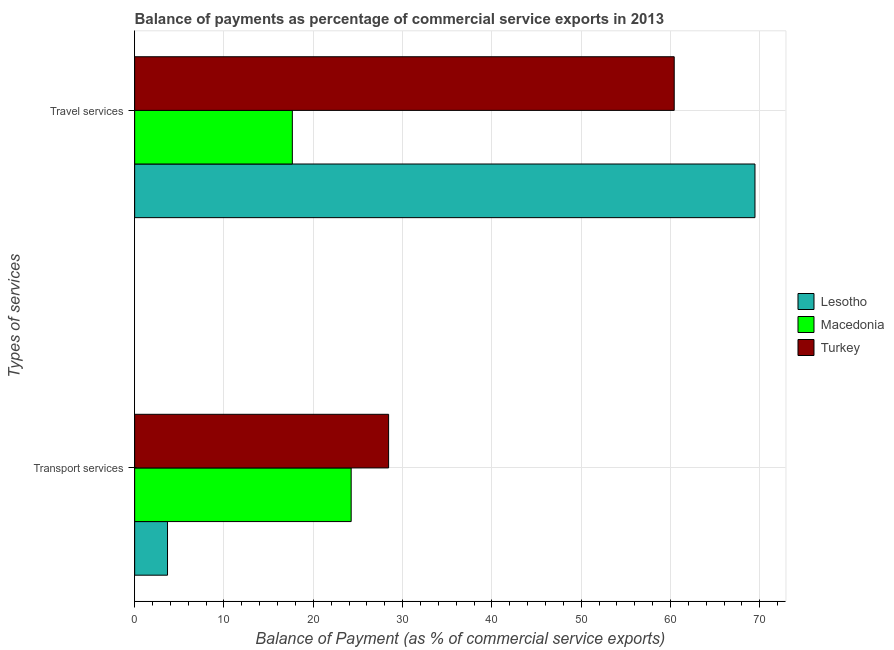How many different coloured bars are there?
Give a very brief answer. 3. How many bars are there on the 1st tick from the top?
Make the answer very short. 3. How many bars are there on the 2nd tick from the bottom?
Make the answer very short. 3. What is the label of the 1st group of bars from the top?
Offer a very short reply. Travel services. What is the balance of payments of travel services in Turkey?
Ensure brevity in your answer.  60.42. Across all countries, what is the maximum balance of payments of transport services?
Your answer should be very brief. 28.43. Across all countries, what is the minimum balance of payments of transport services?
Ensure brevity in your answer.  3.68. In which country was the balance of payments of travel services maximum?
Your response must be concise. Lesotho. In which country was the balance of payments of transport services minimum?
Your response must be concise. Lesotho. What is the total balance of payments of transport services in the graph?
Keep it short and to the point. 56.36. What is the difference between the balance of payments of transport services in Turkey and that in Macedonia?
Your answer should be compact. 4.19. What is the difference between the balance of payments of transport services in Turkey and the balance of payments of travel services in Macedonia?
Provide a succinct answer. 10.78. What is the average balance of payments of travel services per country?
Your answer should be compact. 49.18. What is the difference between the balance of payments of travel services and balance of payments of transport services in Turkey?
Ensure brevity in your answer.  31.98. In how many countries, is the balance of payments of transport services greater than 46 %?
Offer a very short reply. 0. What is the ratio of the balance of payments of travel services in Lesotho to that in Turkey?
Make the answer very short. 1.15. In how many countries, is the balance of payments of transport services greater than the average balance of payments of transport services taken over all countries?
Your answer should be compact. 2. What does the 2nd bar from the top in Transport services represents?
Make the answer very short. Macedonia. What does the 1st bar from the bottom in Travel services represents?
Offer a very short reply. Lesotho. How many bars are there?
Your answer should be very brief. 6. How many legend labels are there?
Make the answer very short. 3. How are the legend labels stacked?
Provide a short and direct response. Vertical. What is the title of the graph?
Offer a terse response. Balance of payments as percentage of commercial service exports in 2013. What is the label or title of the X-axis?
Provide a succinct answer. Balance of Payment (as % of commercial service exports). What is the label or title of the Y-axis?
Your answer should be very brief. Types of services. What is the Balance of Payment (as % of commercial service exports) in Lesotho in Transport services?
Ensure brevity in your answer.  3.68. What is the Balance of Payment (as % of commercial service exports) in Macedonia in Transport services?
Make the answer very short. 24.24. What is the Balance of Payment (as % of commercial service exports) of Turkey in Transport services?
Your response must be concise. 28.43. What is the Balance of Payment (as % of commercial service exports) of Lesotho in Travel services?
Provide a short and direct response. 69.46. What is the Balance of Payment (as % of commercial service exports) of Macedonia in Travel services?
Provide a succinct answer. 17.66. What is the Balance of Payment (as % of commercial service exports) of Turkey in Travel services?
Offer a terse response. 60.42. Across all Types of services, what is the maximum Balance of Payment (as % of commercial service exports) in Lesotho?
Provide a succinct answer. 69.46. Across all Types of services, what is the maximum Balance of Payment (as % of commercial service exports) in Macedonia?
Your response must be concise. 24.24. Across all Types of services, what is the maximum Balance of Payment (as % of commercial service exports) of Turkey?
Provide a succinct answer. 60.42. Across all Types of services, what is the minimum Balance of Payment (as % of commercial service exports) of Lesotho?
Give a very brief answer. 3.68. Across all Types of services, what is the minimum Balance of Payment (as % of commercial service exports) in Macedonia?
Offer a terse response. 17.66. Across all Types of services, what is the minimum Balance of Payment (as % of commercial service exports) of Turkey?
Provide a short and direct response. 28.43. What is the total Balance of Payment (as % of commercial service exports) in Lesotho in the graph?
Your response must be concise. 73.14. What is the total Balance of Payment (as % of commercial service exports) in Macedonia in the graph?
Ensure brevity in your answer.  41.9. What is the total Balance of Payment (as % of commercial service exports) in Turkey in the graph?
Offer a terse response. 88.85. What is the difference between the Balance of Payment (as % of commercial service exports) of Lesotho in Transport services and that in Travel services?
Offer a very short reply. -65.77. What is the difference between the Balance of Payment (as % of commercial service exports) in Macedonia in Transport services and that in Travel services?
Keep it short and to the point. 6.59. What is the difference between the Balance of Payment (as % of commercial service exports) of Turkey in Transport services and that in Travel services?
Offer a terse response. -31.98. What is the difference between the Balance of Payment (as % of commercial service exports) of Lesotho in Transport services and the Balance of Payment (as % of commercial service exports) of Macedonia in Travel services?
Offer a very short reply. -13.98. What is the difference between the Balance of Payment (as % of commercial service exports) in Lesotho in Transport services and the Balance of Payment (as % of commercial service exports) in Turkey in Travel services?
Your answer should be compact. -56.73. What is the difference between the Balance of Payment (as % of commercial service exports) of Macedonia in Transport services and the Balance of Payment (as % of commercial service exports) of Turkey in Travel services?
Your response must be concise. -36.17. What is the average Balance of Payment (as % of commercial service exports) in Lesotho per Types of services?
Keep it short and to the point. 36.57. What is the average Balance of Payment (as % of commercial service exports) of Macedonia per Types of services?
Make the answer very short. 20.95. What is the average Balance of Payment (as % of commercial service exports) in Turkey per Types of services?
Your answer should be compact. 44.42. What is the difference between the Balance of Payment (as % of commercial service exports) in Lesotho and Balance of Payment (as % of commercial service exports) in Macedonia in Transport services?
Make the answer very short. -20.56. What is the difference between the Balance of Payment (as % of commercial service exports) in Lesotho and Balance of Payment (as % of commercial service exports) in Turkey in Transport services?
Provide a short and direct response. -24.75. What is the difference between the Balance of Payment (as % of commercial service exports) in Macedonia and Balance of Payment (as % of commercial service exports) in Turkey in Transport services?
Offer a very short reply. -4.19. What is the difference between the Balance of Payment (as % of commercial service exports) in Lesotho and Balance of Payment (as % of commercial service exports) in Macedonia in Travel services?
Your answer should be compact. 51.8. What is the difference between the Balance of Payment (as % of commercial service exports) of Lesotho and Balance of Payment (as % of commercial service exports) of Turkey in Travel services?
Provide a succinct answer. 9.04. What is the difference between the Balance of Payment (as % of commercial service exports) in Macedonia and Balance of Payment (as % of commercial service exports) in Turkey in Travel services?
Ensure brevity in your answer.  -42.76. What is the ratio of the Balance of Payment (as % of commercial service exports) in Lesotho in Transport services to that in Travel services?
Make the answer very short. 0.05. What is the ratio of the Balance of Payment (as % of commercial service exports) of Macedonia in Transport services to that in Travel services?
Your response must be concise. 1.37. What is the ratio of the Balance of Payment (as % of commercial service exports) of Turkey in Transport services to that in Travel services?
Offer a terse response. 0.47. What is the difference between the highest and the second highest Balance of Payment (as % of commercial service exports) of Lesotho?
Offer a terse response. 65.77. What is the difference between the highest and the second highest Balance of Payment (as % of commercial service exports) of Macedonia?
Make the answer very short. 6.59. What is the difference between the highest and the second highest Balance of Payment (as % of commercial service exports) of Turkey?
Provide a short and direct response. 31.98. What is the difference between the highest and the lowest Balance of Payment (as % of commercial service exports) in Lesotho?
Your answer should be very brief. 65.77. What is the difference between the highest and the lowest Balance of Payment (as % of commercial service exports) in Macedonia?
Provide a short and direct response. 6.59. What is the difference between the highest and the lowest Balance of Payment (as % of commercial service exports) in Turkey?
Your answer should be very brief. 31.98. 